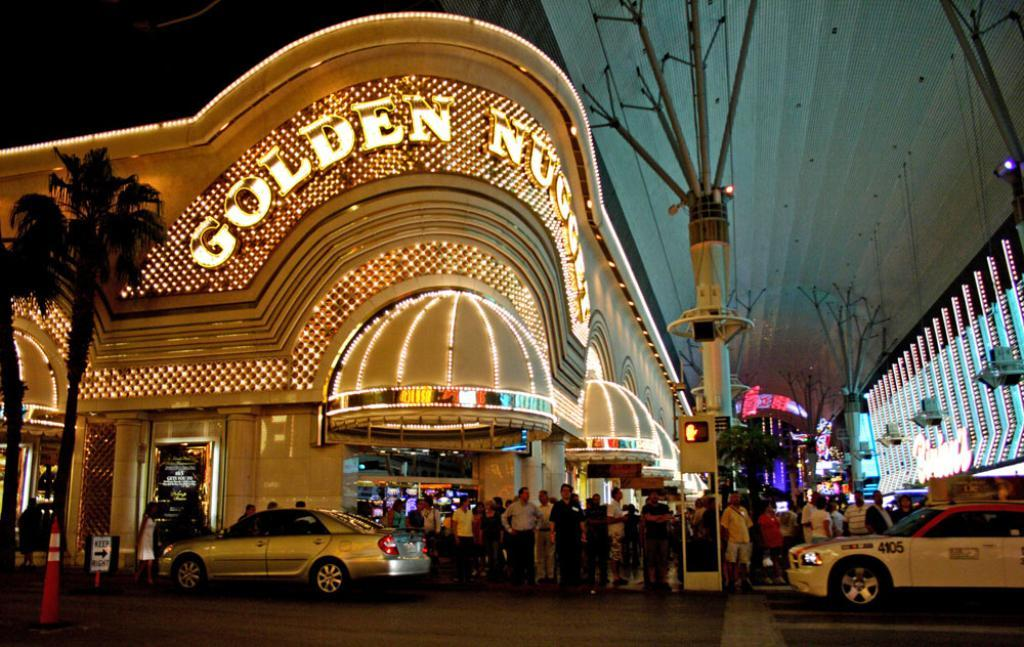Provide a one-sentence caption for the provided image. People gathered outside of the busy Golden Nugget casino. 